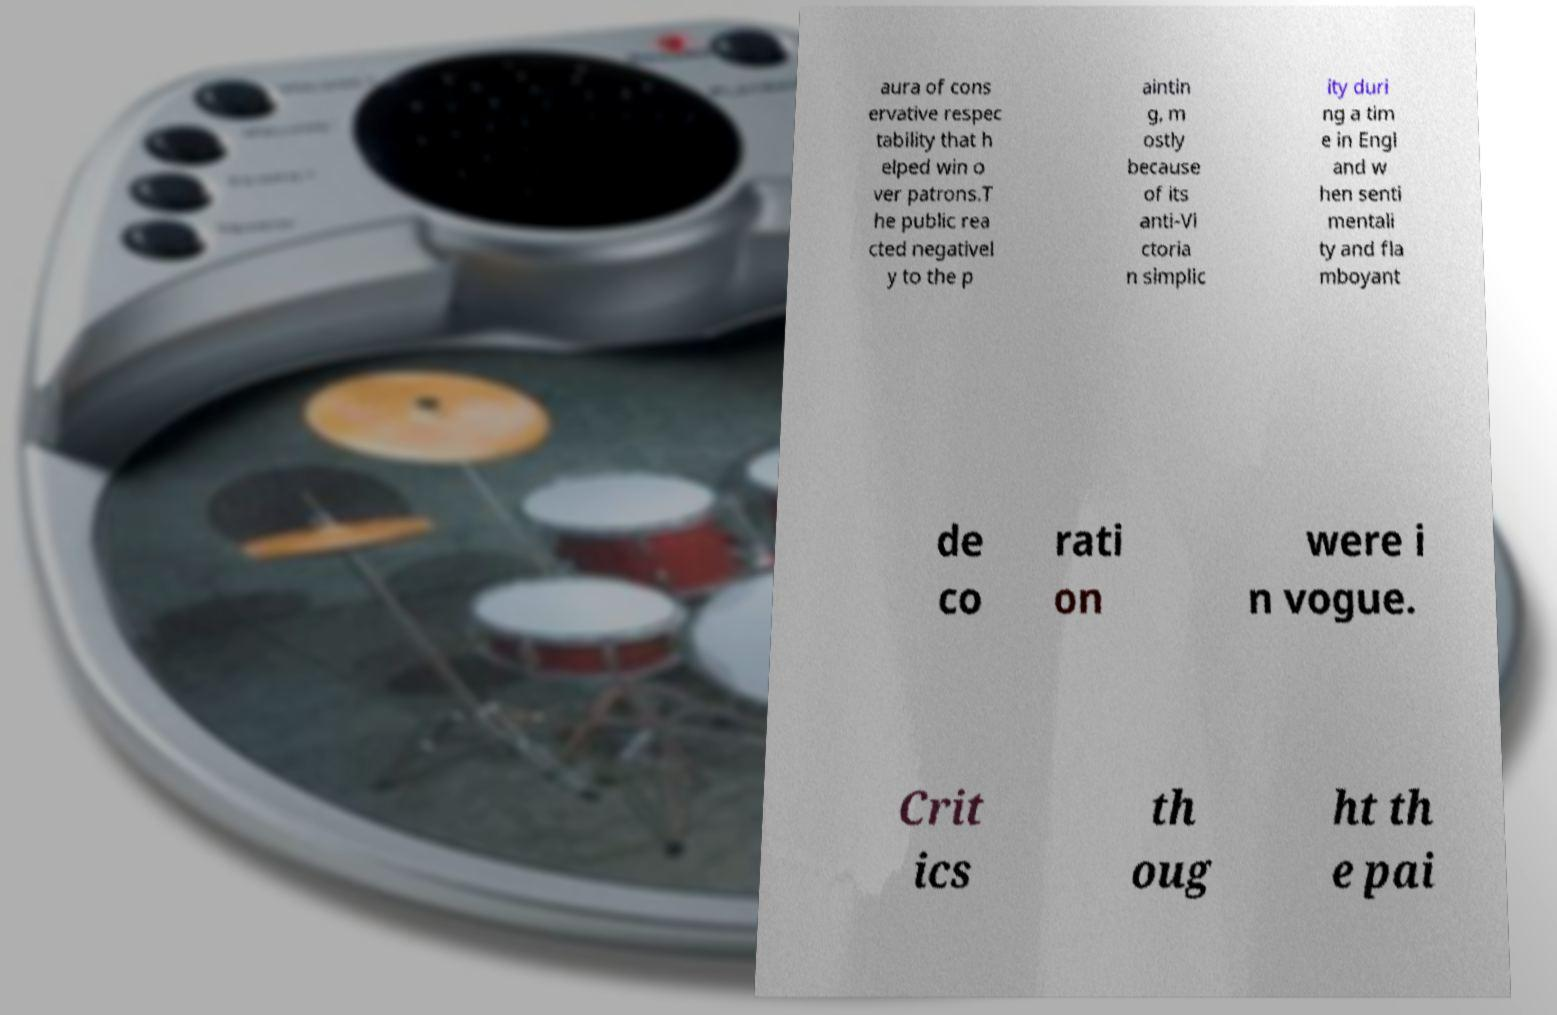What messages or text are displayed in this image? I need them in a readable, typed format. aura of cons ervative respec tability that h elped win o ver patrons.T he public rea cted negativel y to the p aintin g, m ostly because of its anti-Vi ctoria n simplic ity duri ng a tim e in Engl and w hen senti mentali ty and fla mboyant de co rati on were i n vogue. Crit ics th oug ht th e pai 